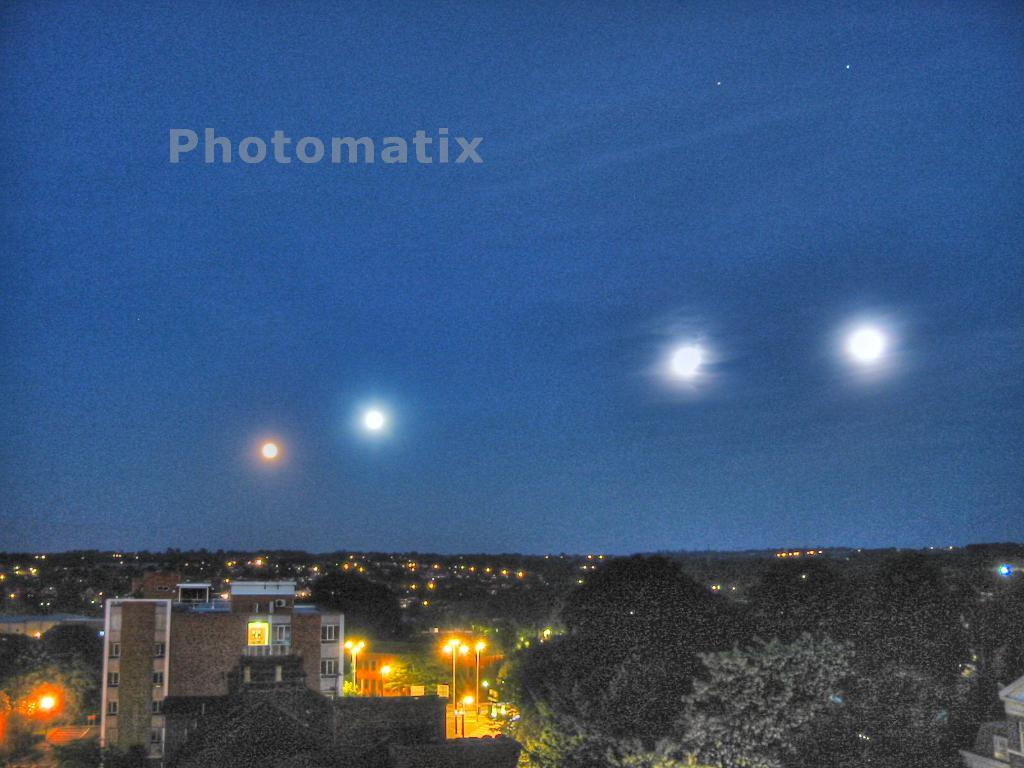What type of structures can be seen in the image? There are buildings in the image. What other natural elements are present in the image? There are trees in the image. What type of lighting is present in the image? There are street lights in the image. What can be seen in the background of the image? The sky is visible in the background of the image. Where is the kitty playing with a pin in the image? There is no kitty or pin present in the image. What type of detail can be seen on the buildings in the image? The provided facts do not mention any specific details on the buildings, so we cannot answer this question definitively. 